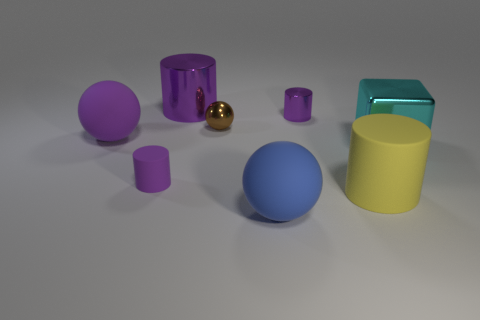Does the large blue sphere in front of the small purple rubber cylinder have the same material as the tiny object in front of the small brown shiny ball?
Offer a very short reply. Yes. The tiny rubber object that is the same shape as the large purple metallic thing is what color?
Keep it short and to the point. Purple. The object to the left of the purple object that is in front of the cyan object is made of what material?
Your answer should be compact. Rubber. Do the tiny object right of the big blue matte ball and the thing on the left side of the purple matte cylinder have the same shape?
Ensure brevity in your answer.  No. What size is the purple cylinder that is in front of the large metallic cylinder and behind the cyan shiny thing?
Your answer should be compact. Small. What number of other things are the same color as the large rubber cylinder?
Provide a succinct answer. 0. Is the tiny sphere that is on the left side of the shiny cube made of the same material as the big blue object?
Keep it short and to the point. No. Is the number of small cylinders in front of the tiny brown metallic ball less than the number of cyan metallic blocks behind the small purple matte thing?
Your answer should be very brief. No. Is there anything else that has the same shape as the cyan shiny thing?
Your answer should be very brief. No. There is a big cylinder that is the same color as the tiny metallic cylinder; what is it made of?
Your response must be concise. Metal. 